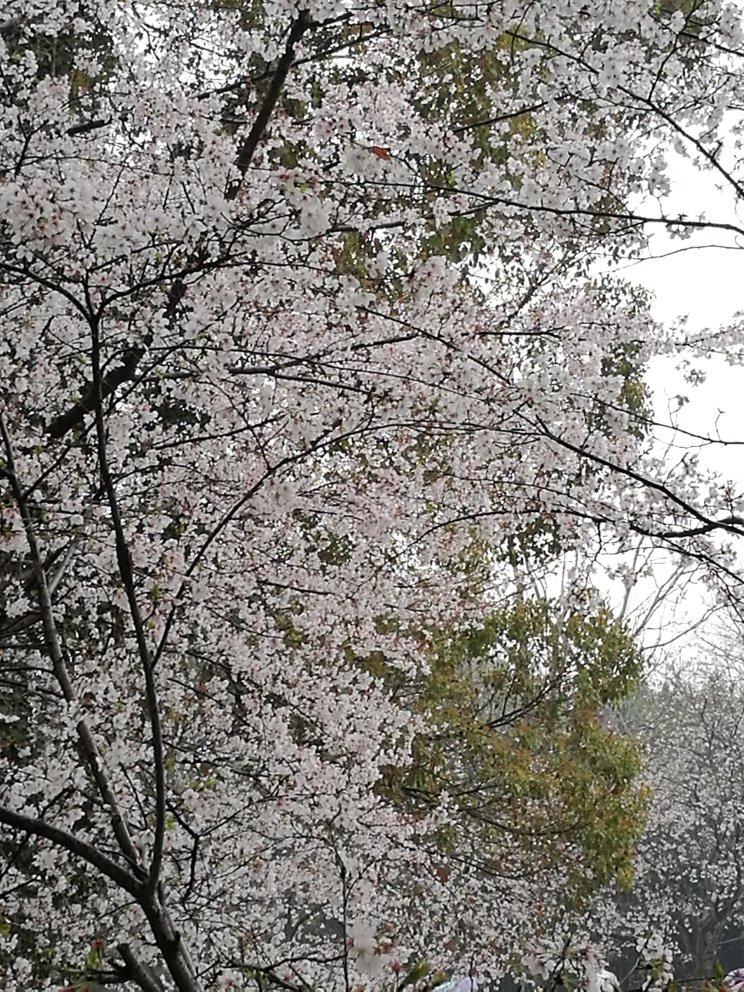What are some possible cultural significances tied to the cherry blossoms seen in the image? Cherry blossoms, or 'sakura', hold profound cultural significance, particularly in Japan, where they symbolize the transient nature of life due to their short blooming period. They are celebrated with 'hanami' parties, where people gather under cherry blossom trees to enjoy the beauty and reflect on life. The symbolism can also extend to themes of rebirth and purity. This imagery might also inspire celebrations of spring, poems, and artwork in various cultures. 